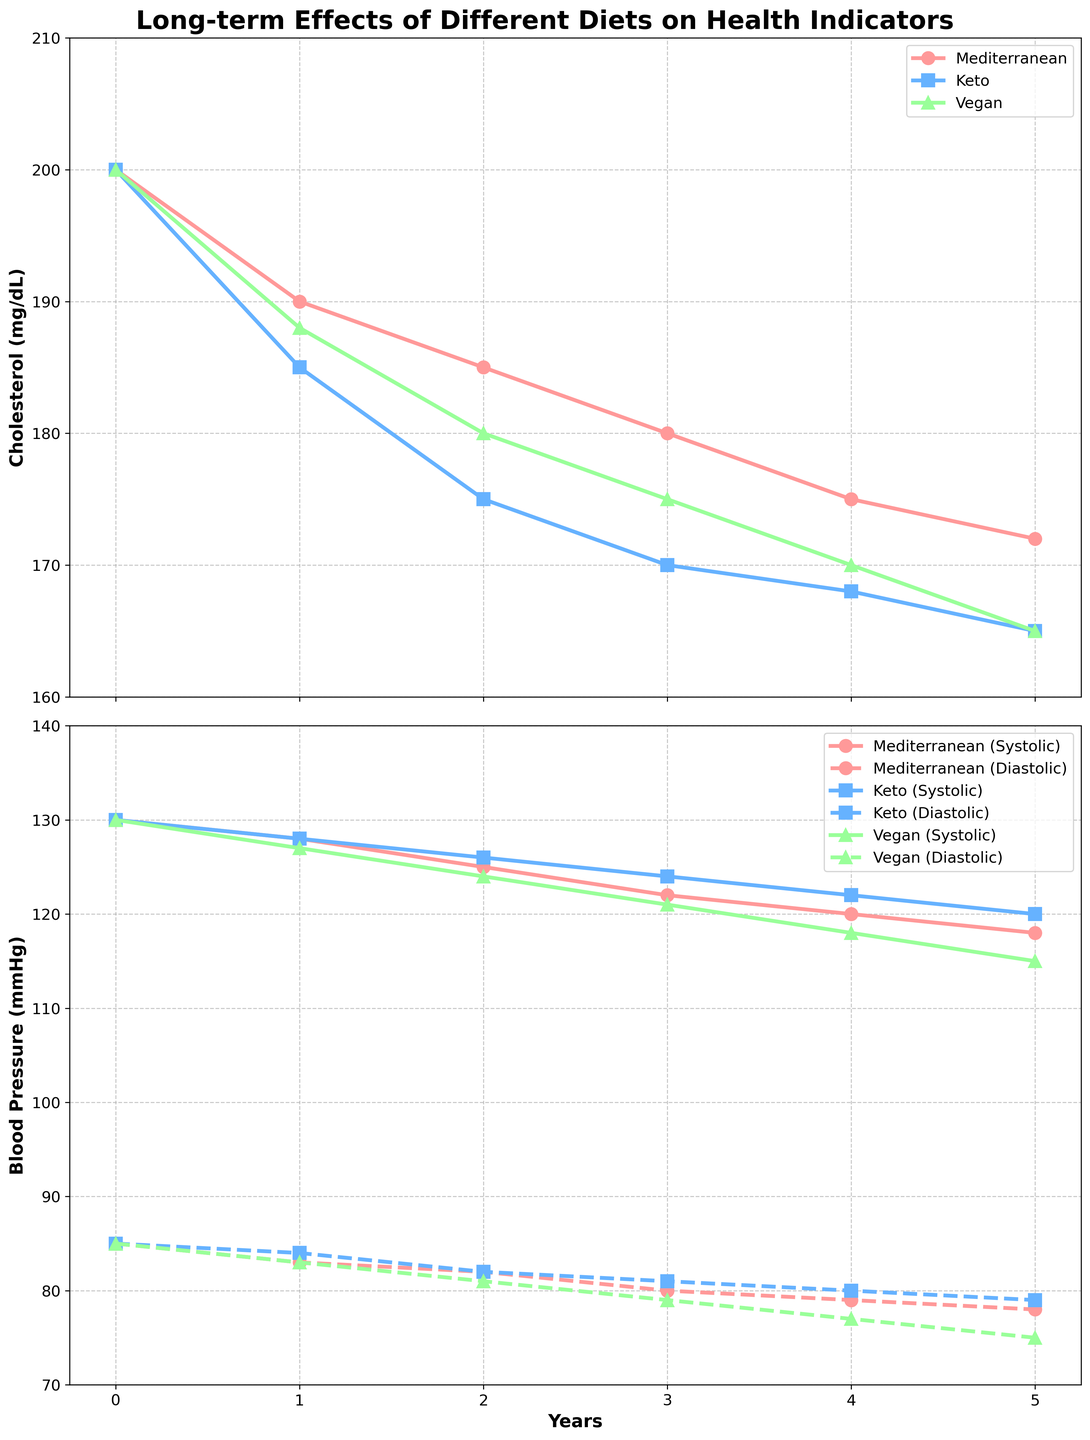Which diet shows the greatest reduction in cholesterol levels over 5 years? Find the difference in cholesterol levels for each diet from year 0 to year 5. Mediterranean: 200 - 172 = 28 mg/dL, Keto: 200 - 165 = 35 mg/dL, Vegan: 200 - 165 = 35 mg/dL. Therefore, Keto and Vegan diets show the greatest reduction in cholesterol levels
Answer: Keto and Vegan How does the systolic blood pressure of the Mediterranean diet compare to the vegan diet at year 3? Check the systolic blood pressure values at year 3 for both diets. Mediterranean = 122 mmHg, Vegan = 121 mmHg. Compare the values to see which is higher or lower
Answer: Mediterranean is 1 mmHg higher What is the trend of diastolic blood pressure for the ketogenic diet over the 5 years? Examine the diastolic blood pressure for the ketogenic diet from year 0 to year 5: 85, 84, 82, 81, 80, 79. The trend shows a continuous decrease
Answer: Decreasing trend Between the Mediterranean and vegan diets, which shows a greater improvement in systolic blood pressure after 5 years? Calculate the reduction in systolic blood pressure from year 0 to year 5 for both diets. Mediterranean: 130 - 118 = 12 mmHg. Vegan: 130 - 115 = 15 mmHg. Compare the reductions
Answer: Vegan By how many mg/dL does the cholesterol level decrease on average per year for the keto diet? Calculate the total decrease in cholesterol over the 5 years and divide by 5. Total decrease = 200 - 165 = 35 mg/dL. Average decrease per year = 35 / 5 = 7 mg/dL
Answer: 7 mg/dL Which diet achieves the lowest diastolic blood pressure by the end of the study? Look at the diastolic blood pressure at year 5 for each diet. Mediterranean = 78 mmHg, Keto = 79 mmHg, Vegan = 75 mmHg. The lowest value is for the vegan diet
Answer: Vegan At year 2, which diet has the highest cholesterol level? Refer to the cholesterol levels at year 2 for each diet. Mediterranean = 185 mg/dL, Keto = 175 mg/dL, Vegan = 180 mg/dL. Identify the highest value
Answer: Mediterranean What are the cholesterol levels for the Mediterranean and keto diets at year 4, and which diet has a lower value? Check the cholesterol levels for both diets at year 4. Mediterranean = 175 mg/dL, Keto = 168 mg/dL. Compare the two values
Answer: Keto How much does the Mediterranean diet reduce diastolic blood pressure by year 3? Note the initial diastolic blood pressure and the value at year 3 for the Mediterranean diet: 85 mmHg (initial) and 80 mmHg (year 3). Calculate the reduction: 85 - 80 = 5 mmHg
Answer: 5 mmHg Compare the starting and ending cholesterol levels for the vegan diet. What is the percentage reduction over the 5 years? Calculate the initial and final cholesterol levels and then find the percentage reduction: Initial = 200 mg/dL, Final = 165 mg/dL, Percentage reduction = [(200 - 165) / 200] * 100 = 17.5%
Answer: 17.5% 